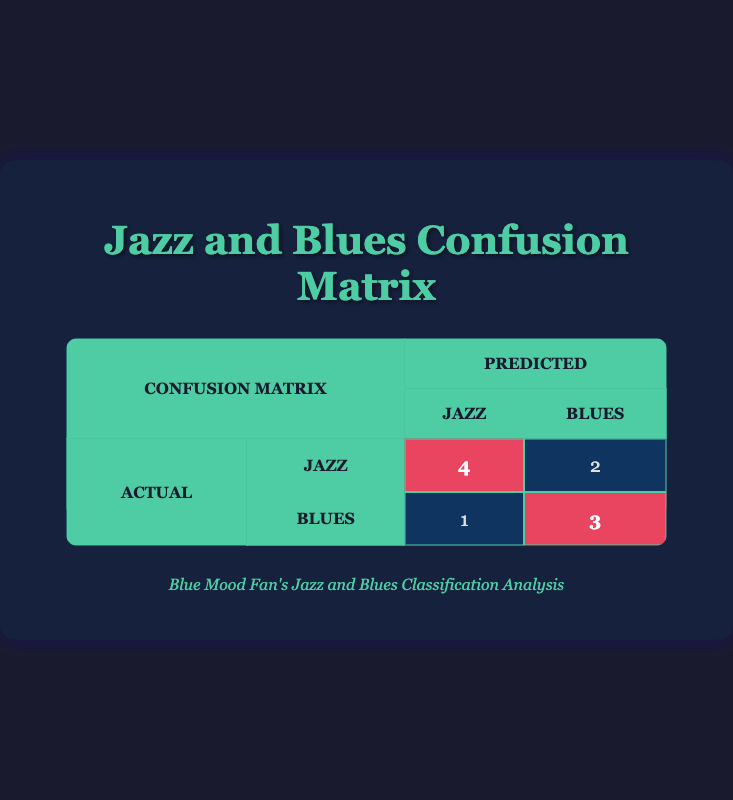What is the number of actual Jazz songs correctly predicted as Jazz? In the confusion matrix, the value at the intersection of the "Actual Jazz" row and "Predicted Jazz" column is 4, which indicates that 4 Jazz songs were correctly predicted as Jazz.
Answer: 4 How many Blues songs did the model predict incorrectly as Jazz? The value at the intersection of the "Actual Blues" row and "Predicted Jazz" column is 1, which shows that 1 Blues song was incorrectly predicted as Jazz.
Answer: 1 What is the total number of songs classified as Jazz by the model? To find the total predicted Jazz songs, we sum the values in the "Predicted Jazz" column: 4 (Actual Jazz) + 1 (Actual Blues) = 5. Therefore, 5 songs were classified as Jazz by the model.
Answer: 5 Are more songs classified as Blues than Jazz? The total number of songs in the "Predicted Blues" column is 2 (Actual Jazz) + 3 (Actual Blues) = 5, while in the "Predicted Jazz" column, there are 5 songs. Since both are equal, the answer is no, there are not more Blues songs classified than Jazz.
Answer: No What is the difference between Jazz songs correctly predicted and Blues songs correctly predicted? The number of correctly predicted Jazz songs is 4 (from "Actual Jazz" to "Predicted Jazz") and for Blues, it is 3 (from "Actual Blues" to "Predicted Blues"). Calculating the difference: 4 - 3 = 1. Therefore, the difference is 1.
Answer: 1 How many total incorrect predictions were made? Incorrect predictions occur when the model predicted a song incorrectly. This includes: 1 Blues song misclassified as Jazz and 2 Jazz songs misclassified as Blues, summing these gives us a total of 3 incorrect predictions (1 + 2 = 3).
Answer: 3 How many more songs did the model classify as Jazz compared to incorrectly classified Blues? The total Jazz predictions are 5 (which includes both correct and incorrect predictions), and the number of incorrectly classified Blues is 1. Therefore, the difference is 5 - 1 = 4. The model predicts 4 more songs as Jazz than incorrectly classified Blues.
Answer: 4 Is it true that all Blues songs were classified correctly? From the confusion matrix, we see that there are 3 Blues songs correctly predicted, but there is also 1 Blues song that was incorrectly predicted as Jazz. Therefore, it is false that all Blues songs were classified correctly.
Answer: No What percentage of the total songs were correctly predicted as Blues? The total number of songs is 10. The correctly predicted Blues songs are 3. To find the percentage, we calculate (3 / 10) * 100, which gives us 30%. Therefore, the percentage of total songs correctly predicted as Blues is 30%.
Answer: 30% 